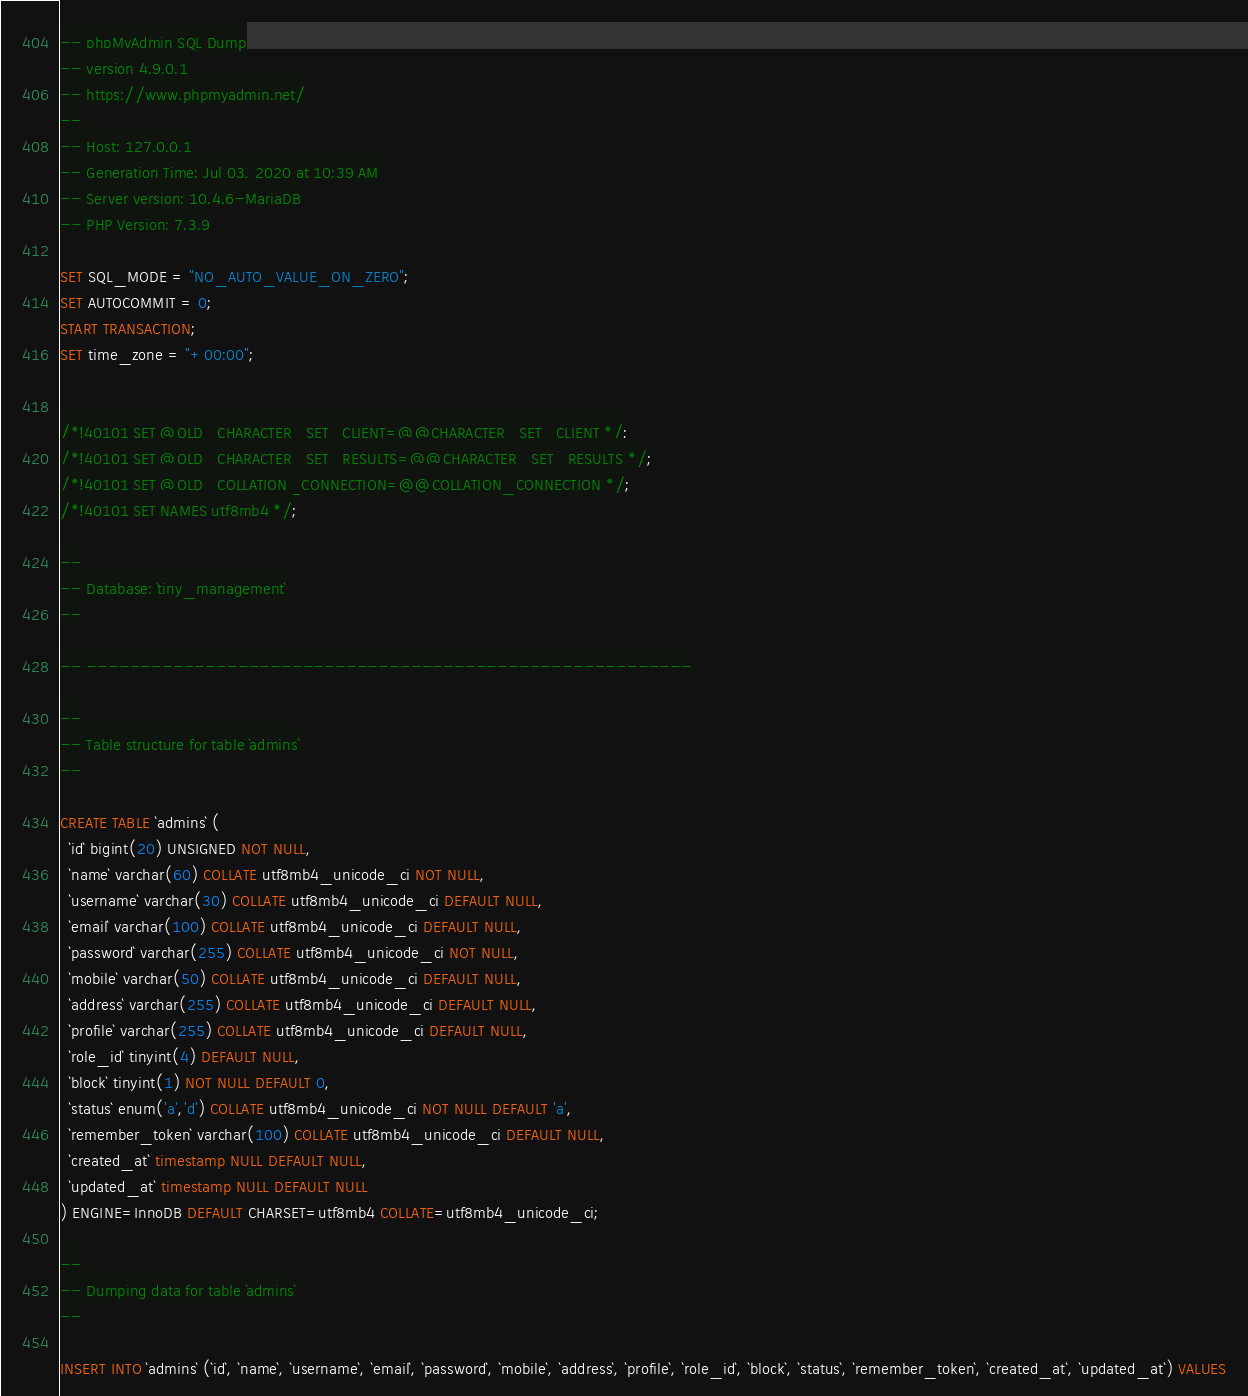<code> <loc_0><loc_0><loc_500><loc_500><_SQL_>-- phpMyAdmin SQL Dump
-- version 4.9.0.1
-- https://www.phpmyadmin.net/
--
-- Host: 127.0.0.1
-- Generation Time: Jul 03, 2020 at 10:39 AM
-- Server version: 10.4.6-MariaDB
-- PHP Version: 7.3.9

SET SQL_MODE = "NO_AUTO_VALUE_ON_ZERO";
SET AUTOCOMMIT = 0;
START TRANSACTION;
SET time_zone = "+00:00";


/*!40101 SET @OLD_CHARACTER_SET_CLIENT=@@CHARACTER_SET_CLIENT */;
/*!40101 SET @OLD_CHARACTER_SET_RESULTS=@@CHARACTER_SET_RESULTS */;
/*!40101 SET @OLD_COLLATION_CONNECTION=@@COLLATION_CONNECTION */;
/*!40101 SET NAMES utf8mb4 */;

--
-- Database: `tiny_management`
--

-- --------------------------------------------------------

--
-- Table structure for table `admins`
--

CREATE TABLE `admins` (
  `id` bigint(20) UNSIGNED NOT NULL,
  `name` varchar(60) COLLATE utf8mb4_unicode_ci NOT NULL,
  `username` varchar(30) COLLATE utf8mb4_unicode_ci DEFAULT NULL,
  `email` varchar(100) COLLATE utf8mb4_unicode_ci DEFAULT NULL,
  `password` varchar(255) COLLATE utf8mb4_unicode_ci NOT NULL,
  `mobile` varchar(50) COLLATE utf8mb4_unicode_ci DEFAULT NULL,
  `address` varchar(255) COLLATE utf8mb4_unicode_ci DEFAULT NULL,
  `profile` varchar(255) COLLATE utf8mb4_unicode_ci DEFAULT NULL,
  `role_id` tinyint(4) DEFAULT NULL,
  `block` tinyint(1) NOT NULL DEFAULT 0,
  `status` enum('a','d') COLLATE utf8mb4_unicode_ci NOT NULL DEFAULT 'a',
  `remember_token` varchar(100) COLLATE utf8mb4_unicode_ci DEFAULT NULL,
  `created_at` timestamp NULL DEFAULT NULL,
  `updated_at` timestamp NULL DEFAULT NULL
) ENGINE=InnoDB DEFAULT CHARSET=utf8mb4 COLLATE=utf8mb4_unicode_ci;

--
-- Dumping data for table `admins`
--

INSERT INTO `admins` (`id`, `name`, `username`, `email`, `password`, `mobile`, `address`, `profile`, `role_id`, `block`, `status`, `remember_token`, `created_at`, `updated_at`) VALUES</code> 